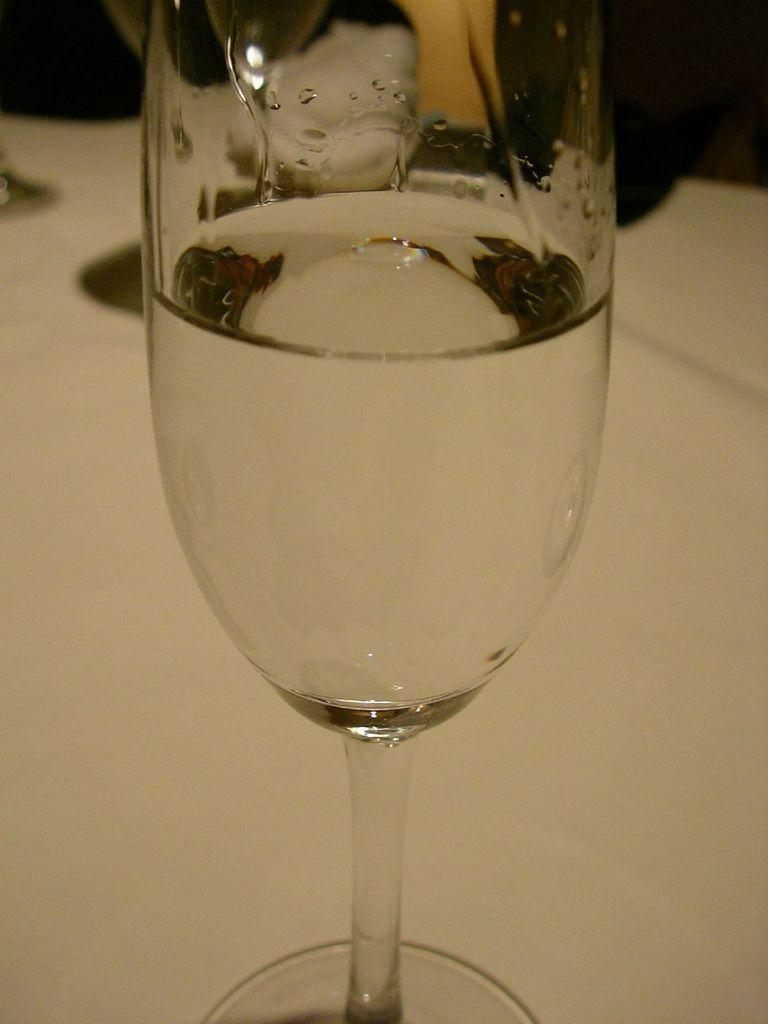What is in the glass that is visible in the image? The glass contains water in the image. What is the glass placed on in the image? The glass is placed on a surface in the image. What type of metal is the frog made of in the image? There is no frog present in the image, and therefore no such metal can be identified. 